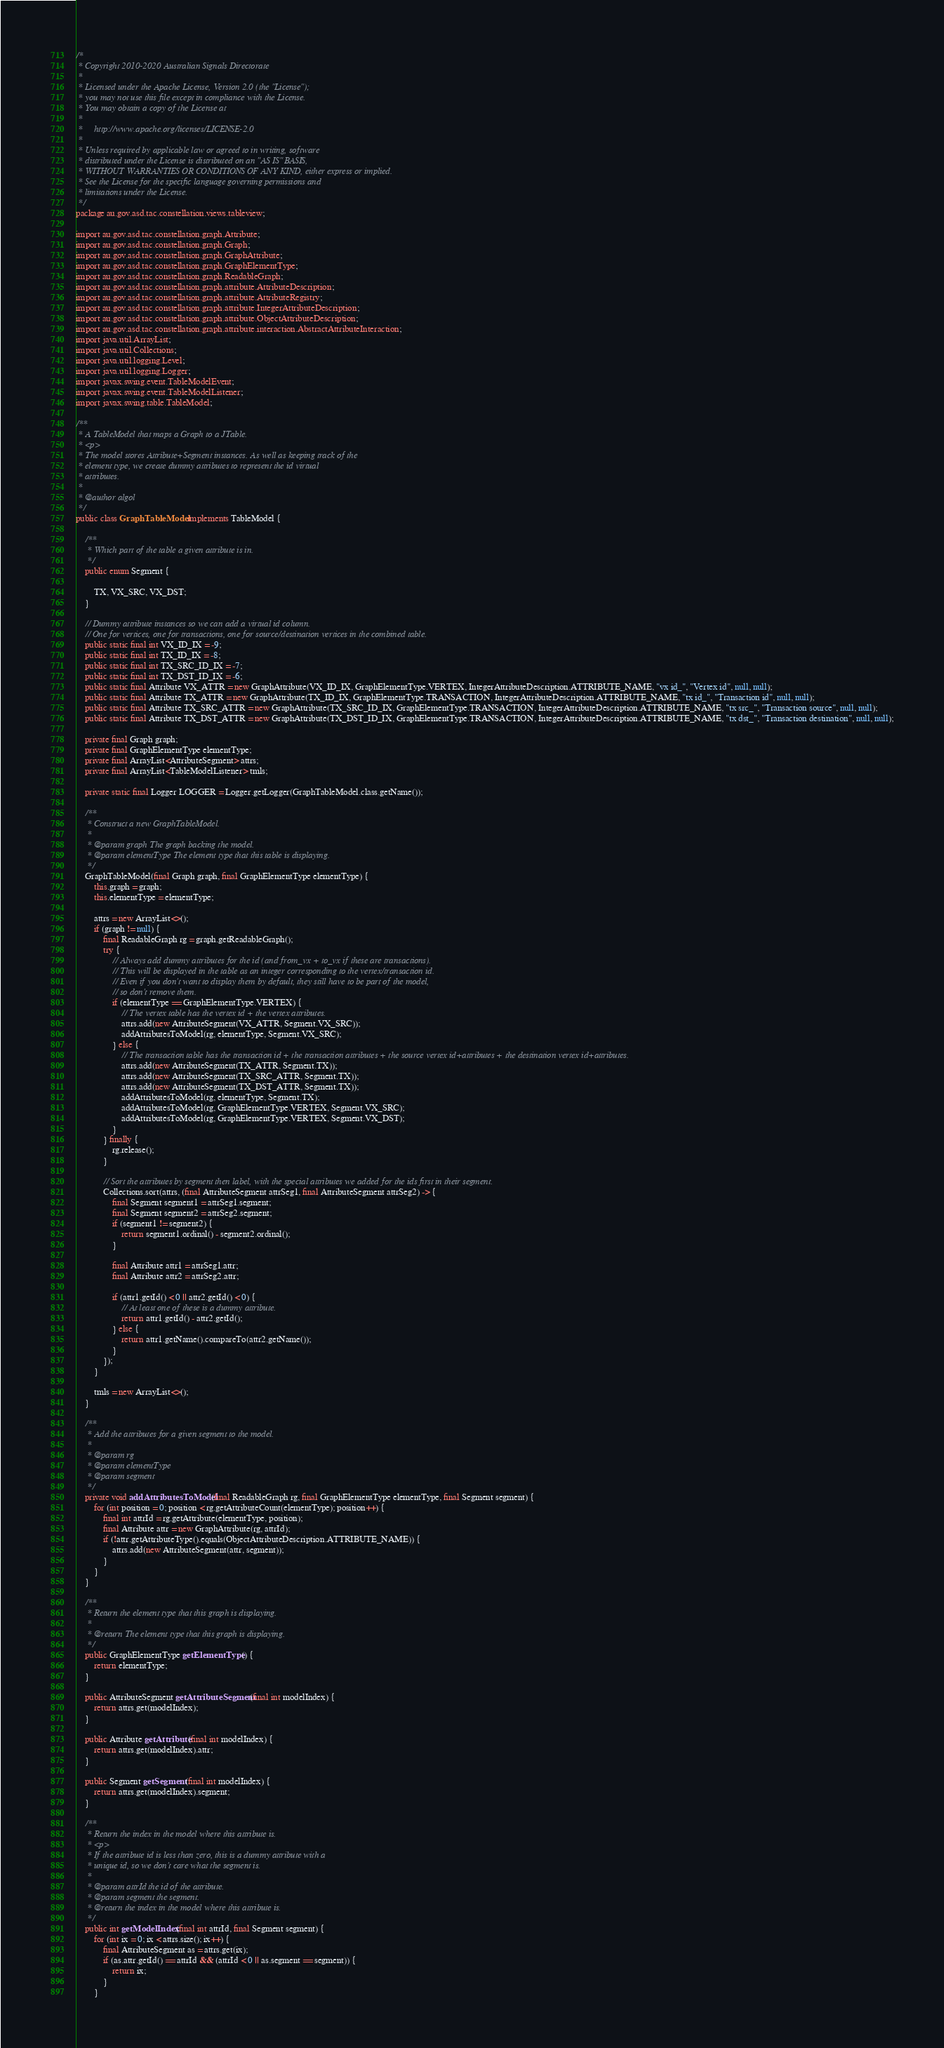Convert code to text. <code><loc_0><loc_0><loc_500><loc_500><_Java_>/*
 * Copyright 2010-2020 Australian Signals Directorate
 *
 * Licensed under the Apache License, Version 2.0 (the "License");
 * you may not use this file except in compliance with the License.
 * You may obtain a copy of the License at
 *
 *     http://www.apache.org/licenses/LICENSE-2.0
 *
 * Unless required by applicable law or agreed to in writing, software
 * distributed under the License is distributed on an "AS IS" BASIS,
 * WITHOUT WARRANTIES OR CONDITIONS OF ANY KIND, either express or implied.
 * See the License for the specific language governing permissions and
 * limitations under the License.
 */
package au.gov.asd.tac.constellation.views.tableview;

import au.gov.asd.tac.constellation.graph.Attribute;
import au.gov.asd.tac.constellation.graph.Graph;
import au.gov.asd.tac.constellation.graph.GraphAttribute;
import au.gov.asd.tac.constellation.graph.GraphElementType;
import au.gov.asd.tac.constellation.graph.ReadableGraph;
import au.gov.asd.tac.constellation.graph.attribute.AttributeDescription;
import au.gov.asd.tac.constellation.graph.attribute.AttributeRegistry;
import au.gov.asd.tac.constellation.graph.attribute.IntegerAttributeDescription;
import au.gov.asd.tac.constellation.graph.attribute.ObjectAttributeDescription;
import au.gov.asd.tac.constellation.graph.attribute.interaction.AbstractAttributeInteraction;
import java.util.ArrayList;
import java.util.Collections;
import java.util.logging.Level;
import java.util.logging.Logger;
import javax.swing.event.TableModelEvent;
import javax.swing.event.TableModelListener;
import javax.swing.table.TableModel;

/**
 * A TableModel that maps a Graph to a JTable.
 * <p>
 * The model stores Attribute+Segment instances. As well as keeping track of the
 * element type, we create dummy attributes to represent the id virtual
 * attributes.
 *
 * @author algol
 */
public class GraphTableModel implements TableModel {

    /**
     * Which part of the table a given attribute is in.
     */
    public enum Segment {

        TX, VX_SRC, VX_DST;
    }

    // Dummy attribute instances so we can add a virtual id column.
    // One for vertices, one for transactions, one for source/destination vertices in the combined table.
    public static final int VX_ID_IX = -9;
    public static final int TX_ID_IX = -8;
    public static final int TX_SRC_ID_IX = -7;
    public static final int TX_DST_ID_IX = -6;
    public static final Attribute VX_ATTR = new GraphAttribute(VX_ID_IX, GraphElementType.VERTEX, IntegerAttributeDescription.ATTRIBUTE_NAME, "vx id_", "Vertex id", null, null);
    public static final Attribute TX_ATTR = new GraphAttribute(TX_ID_IX, GraphElementType.TRANSACTION, IntegerAttributeDescription.ATTRIBUTE_NAME, "tx id_", "Transaction id", null, null);
    public static final Attribute TX_SRC_ATTR = new GraphAttribute(TX_SRC_ID_IX, GraphElementType.TRANSACTION, IntegerAttributeDescription.ATTRIBUTE_NAME, "tx src_", "Transaction source", null, null);
    public static final Attribute TX_DST_ATTR = new GraphAttribute(TX_DST_ID_IX, GraphElementType.TRANSACTION, IntegerAttributeDescription.ATTRIBUTE_NAME, "tx dst_", "Transaction destination", null, null);

    private final Graph graph;
    private final GraphElementType elementType;
    private final ArrayList<AttributeSegment> attrs;
    private final ArrayList<TableModelListener> tmls;

    private static final Logger LOGGER = Logger.getLogger(GraphTableModel.class.getName());

    /**
     * Construct a new GraphTableModel.
     *
     * @param graph The graph backing the model.
     * @param elementType The element type that this table is displaying.
     */
    GraphTableModel(final Graph graph, final GraphElementType elementType) {
        this.graph = graph;
        this.elementType = elementType;

        attrs = new ArrayList<>();
        if (graph != null) {
            final ReadableGraph rg = graph.getReadableGraph();
            try {
                // Always add dummy attributes for the id (and from_vx + to_vx if these are transactions).
                // This will be displayed in the table as an integer corresponding to the vertex/transaction id.
                // Even if you don't want to display them by default, they still have to be part of the model,
                // so don't remove them.
                if (elementType == GraphElementType.VERTEX) {
                    // The vertex table has the vertex id + the vertex attributes.
                    attrs.add(new AttributeSegment(VX_ATTR, Segment.VX_SRC));
                    addAttributesToModel(rg, elementType, Segment.VX_SRC);
                } else {
                    // The transaction table has the transaction id + the transaction attributes + the source vertex id+attributes + the destination vertex id+attributes.
                    attrs.add(new AttributeSegment(TX_ATTR, Segment.TX));
                    attrs.add(new AttributeSegment(TX_SRC_ATTR, Segment.TX));
                    attrs.add(new AttributeSegment(TX_DST_ATTR, Segment.TX));
                    addAttributesToModel(rg, elementType, Segment.TX);
                    addAttributesToModel(rg, GraphElementType.VERTEX, Segment.VX_SRC);
                    addAttributesToModel(rg, GraphElementType.VERTEX, Segment.VX_DST);
                }
            } finally {
                rg.release();
            }

            // Sort the attributes by segment then label, with the special attributes we added for the ids first in their segment.
            Collections.sort(attrs, (final AttributeSegment attrSeg1, final AttributeSegment attrSeg2) -> {
                final Segment segment1 = attrSeg1.segment;
                final Segment segment2 = attrSeg2.segment;
                if (segment1 != segment2) {
                    return segment1.ordinal() - segment2.ordinal();
                }

                final Attribute attr1 = attrSeg1.attr;
                final Attribute attr2 = attrSeg2.attr;

                if (attr1.getId() < 0 || attr2.getId() < 0) {
                    // At least one of these is a dummy attribute.
                    return attr1.getId() - attr2.getId();
                } else {
                    return attr1.getName().compareTo(attr2.getName());
                }
            });
        }

        tmls = new ArrayList<>();
    }

    /**
     * Add the attributes for a given segment to the model.
     *
     * @param rg
     * @param elementType
     * @param segment
     */
    private void addAttributesToModel(final ReadableGraph rg, final GraphElementType elementType, final Segment segment) {
        for (int position = 0; position < rg.getAttributeCount(elementType); position++) {
            final int attrId = rg.getAttribute(elementType, position);
            final Attribute attr = new GraphAttribute(rg, attrId);
            if (!attr.getAttributeType().equals(ObjectAttributeDescription.ATTRIBUTE_NAME)) {
                attrs.add(new AttributeSegment(attr, segment));
            }
        }
    }

    /**
     * Return the element type that this graph is displaying.
     *
     * @return The element type that this graph is displaying.
     */
    public GraphElementType getElementType() {
        return elementType;
    }

    public AttributeSegment getAttributeSegment(final int modelIndex) {
        return attrs.get(modelIndex);
    }

    public Attribute getAttribute(final int modelIndex) {
        return attrs.get(modelIndex).attr;
    }

    public Segment getSegment(final int modelIndex) {
        return attrs.get(modelIndex).segment;
    }

    /**
     * Return the index in the model where this attribute is.
     * <p>
     * If the attribute id is less than zero, this is a dummy attribute with a
     * unique id, so we don't care what the segment is.
     *
     * @param attrId the id of the attribute.
     * @param segment the segment.
     * @return the index in the model where this attribute is.
     */
    public int getModelIndex(final int attrId, final Segment segment) {
        for (int ix = 0; ix < attrs.size(); ix++) {
            final AttributeSegment as = attrs.get(ix);
            if (as.attr.getId() == attrId && (attrId < 0 || as.segment == segment)) {
                return ix;
            }
        }
</code> 